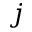<formula> <loc_0><loc_0><loc_500><loc_500>j</formula> 